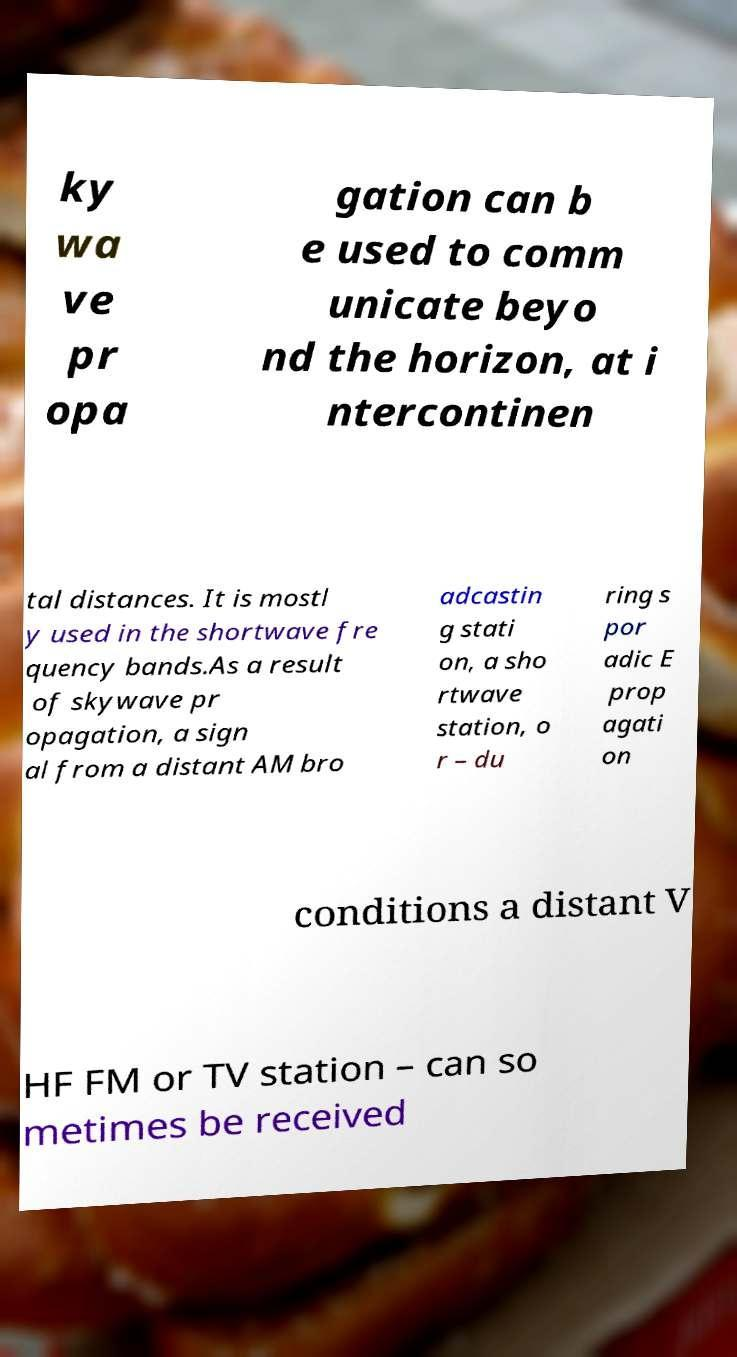Can you read and provide the text displayed in the image?This photo seems to have some interesting text. Can you extract and type it out for me? ky wa ve pr opa gation can b e used to comm unicate beyo nd the horizon, at i ntercontinen tal distances. It is mostl y used in the shortwave fre quency bands.As a result of skywave pr opagation, a sign al from a distant AM bro adcastin g stati on, a sho rtwave station, o r – du ring s por adic E prop agati on conditions a distant V HF FM or TV station – can so metimes be received 